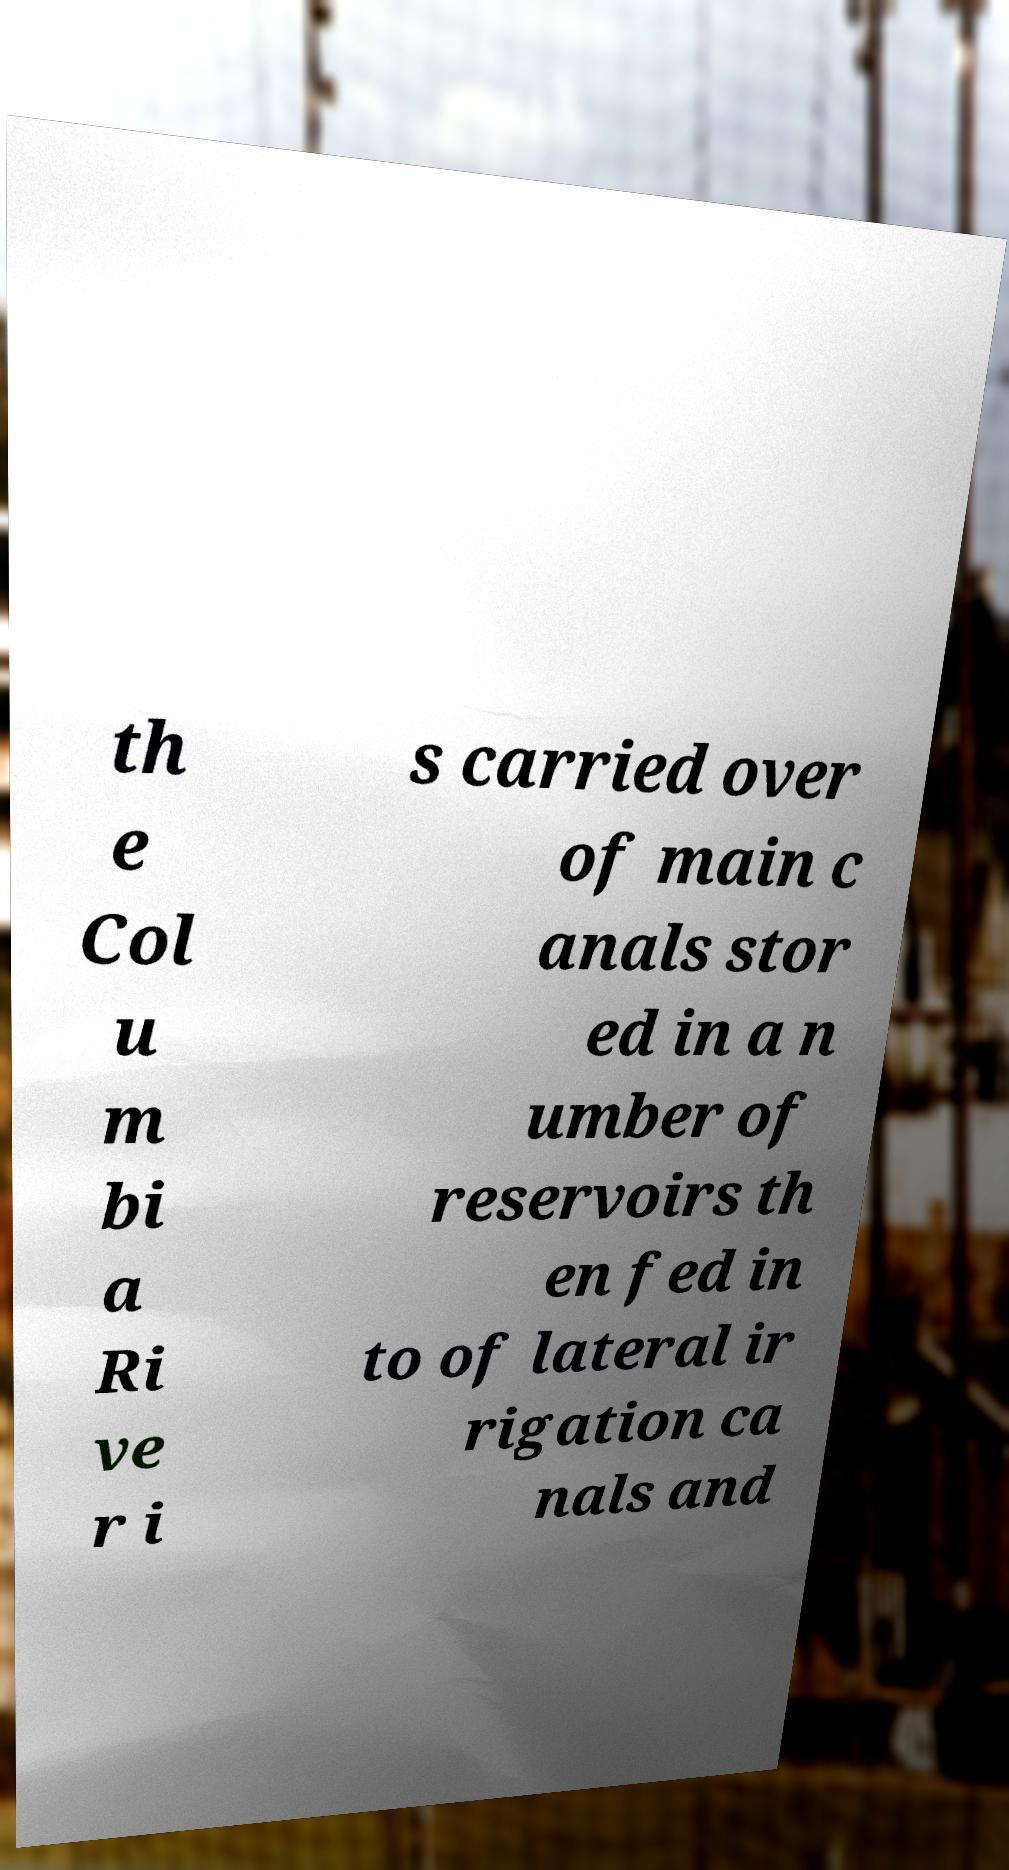What messages or text are displayed in this image? I need them in a readable, typed format. th e Col u m bi a Ri ve r i s carried over of main c anals stor ed in a n umber of reservoirs th en fed in to of lateral ir rigation ca nals and 